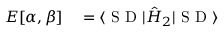<formula> <loc_0><loc_0><loc_500><loc_500>\begin{array} { r l } { E [ \alpha , \beta ] } & = \langle S D | \hat { H } _ { 2 } | S D \rangle } \end{array}</formula> 